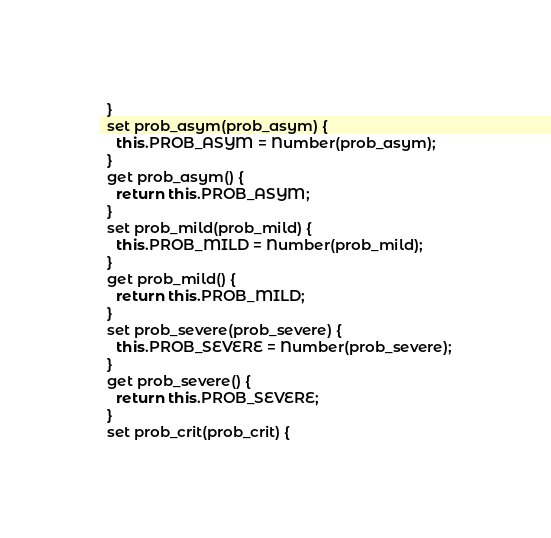Convert code to text. <code><loc_0><loc_0><loc_500><loc_500><_JavaScript_>  }
  set prob_asym(prob_asym) {
    this.PROB_ASYM = Number(prob_asym);
  }
  get prob_asym() {
    return this.PROB_ASYM;
  }
  set prob_mild(prob_mild) {
    this.PROB_MILD = Number(prob_mild);
  }
  get prob_mild() {
    return this.PROB_MILD;
  }
  set prob_severe(prob_severe) {
    this.PROB_SEVERE = Number(prob_severe);
  }
  get prob_severe() {
    return this.PROB_SEVERE;
  }
  set prob_crit(prob_crit) {</code> 